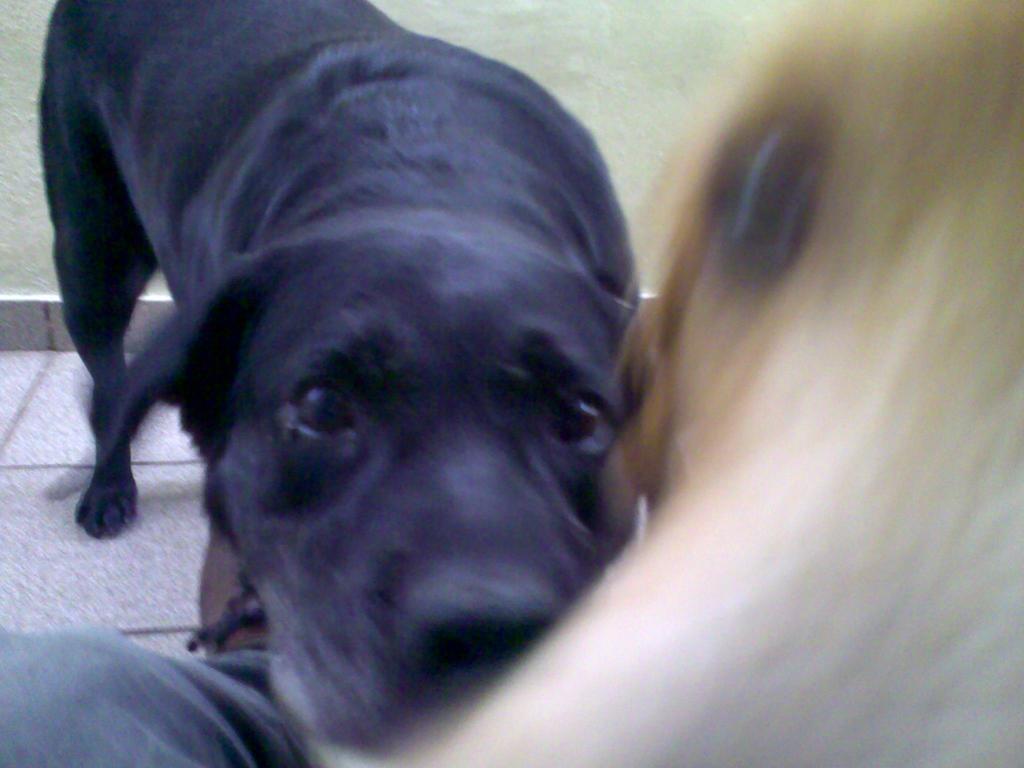How would you summarize this image in a sentence or two? In this image I see a dog which is of black in color and I see that it is blurred over here and I see a leg of a person and I see the path. 